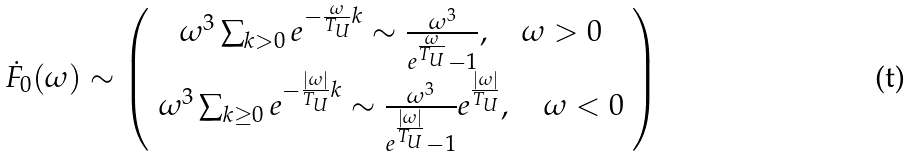<formula> <loc_0><loc_0><loc_500><loc_500>\dot { F } _ { 0 } ( \omega ) \sim \left ( \begin{array} { c } \omega ^ { 3 } \sum _ { k > 0 } e ^ { - \frac { \omega } { T _ { U } } k } \sim \frac { \omega ^ { 3 } } { e ^ { \frac { \omega } { T _ { U } } } - 1 } , \quad \omega > 0 \\ \omega ^ { 3 } \sum _ { k \geq 0 } e ^ { - \frac { | \omega | } { T _ { U } } k } \sim \frac { \omega ^ { 3 } } { e ^ { \frac { | \omega | } { T _ { U } } } - 1 } e ^ { \frac { | \omega | } { T _ { U } } } , \quad \omega < 0 \end{array} \right )</formula> 